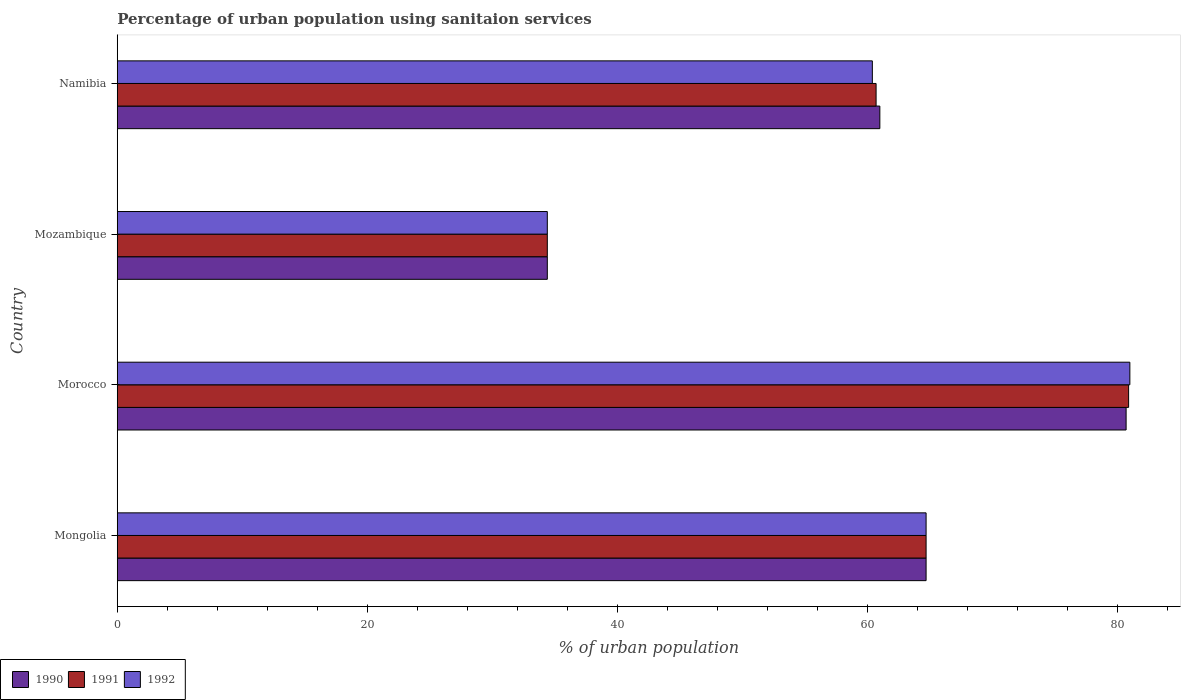How many different coloured bars are there?
Give a very brief answer. 3. Are the number of bars on each tick of the Y-axis equal?
Your answer should be very brief. Yes. How many bars are there on the 2nd tick from the top?
Offer a very short reply. 3. What is the label of the 1st group of bars from the top?
Keep it short and to the point. Namibia. In how many cases, is the number of bars for a given country not equal to the number of legend labels?
Make the answer very short. 0. What is the percentage of urban population using sanitaion services in 1990 in Mozambique?
Keep it short and to the point. 34.4. Across all countries, what is the maximum percentage of urban population using sanitaion services in 1990?
Offer a terse response. 80.7. Across all countries, what is the minimum percentage of urban population using sanitaion services in 1991?
Make the answer very short. 34.4. In which country was the percentage of urban population using sanitaion services in 1990 maximum?
Give a very brief answer. Morocco. In which country was the percentage of urban population using sanitaion services in 1991 minimum?
Provide a short and direct response. Mozambique. What is the total percentage of urban population using sanitaion services in 1992 in the graph?
Provide a short and direct response. 240.5. What is the difference between the percentage of urban population using sanitaion services in 1992 in Morocco and that in Mozambique?
Offer a very short reply. 46.6. What is the difference between the percentage of urban population using sanitaion services in 1990 in Morocco and the percentage of urban population using sanitaion services in 1992 in Mozambique?
Offer a terse response. 46.3. What is the average percentage of urban population using sanitaion services in 1992 per country?
Make the answer very short. 60.12. What is the difference between the percentage of urban population using sanitaion services in 1990 and percentage of urban population using sanitaion services in 1991 in Namibia?
Provide a short and direct response. 0.3. In how many countries, is the percentage of urban population using sanitaion services in 1990 greater than 32 %?
Your response must be concise. 4. What is the ratio of the percentage of urban population using sanitaion services in 1990 in Mozambique to that in Namibia?
Provide a succinct answer. 0.56. Is the percentage of urban population using sanitaion services in 1992 in Mongolia less than that in Morocco?
Offer a very short reply. Yes. What is the difference between the highest and the second highest percentage of urban population using sanitaion services in 1990?
Provide a short and direct response. 16. What is the difference between the highest and the lowest percentage of urban population using sanitaion services in 1992?
Your answer should be compact. 46.6. In how many countries, is the percentage of urban population using sanitaion services in 1990 greater than the average percentage of urban population using sanitaion services in 1990 taken over all countries?
Your answer should be very brief. 3. What does the 2nd bar from the bottom in Namibia represents?
Offer a terse response. 1991. Is it the case that in every country, the sum of the percentage of urban population using sanitaion services in 1990 and percentage of urban population using sanitaion services in 1991 is greater than the percentage of urban population using sanitaion services in 1992?
Your answer should be compact. Yes. Are all the bars in the graph horizontal?
Ensure brevity in your answer.  Yes. How many countries are there in the graph?
Give a very brief answer. 4. Are the values on the major ticks of X-axis written in scientific E-notation?
Your answer should be very brief. No. Does the graph contain any zero values?
Offer a terse response. No. How many legend labels are there?
Ensure brevity in your answer.  3. How are the legend labels stacked?
Offer a very short reply. Horizontal. What is the title of the graph?
Provide a short and direct response. Percentage of urban population using sanitaion services. Does "2015" appear as one of the legend labels in the graph?
Make the answer very short. No. What is the label or title of the X-axis?
Keep it short and to the point. % of urban population. What is the % of urban population in 1990 in Mongolia?
Your response must be concise. 64.7. What is the % of urban population of 1991 in Mongolia?
Provide a short and direct response. 64.7. What is the % of urban population in 1992 in Mongolia?
Your answer should be compact. 64.7. What is the % of urban population of 1990 in Morocco?
Your answer should be very brief. 80.7. What is the % of urban population of 1991 in Morocco?
Give a very brief answer. 80.9. What is the % of urban population in 1992 in Morocco?
Your answer should be compact. 81. What is the % of urban population of 1990 in Mozambique?
Offer a terse response. 34.4. What is the % of urban population in 1991 in Mozambique?
Keep it short and to the point. 34.4. What is the % of urban population in 1992 in Mozambique?
Make the answer very short. 34.4. What is the % of urban population of 1990 in Namibia?
Your response must be concise. 61. What is the % of urban population of 1991 in Namibia?
Your answer should be very brief. 60.7. What is the % of urban population of 1992 in Namibia?
Your answer should be very brief. 60.4. Across all countries, what is the maximum % of urban population of 1990?
Ensure brevity in your answer.  80.7. Across all countries, what is the maximum % of urban population in 1991?
Offer a very short reply. 80.9. Across all countries, what is the minimum % of urban population in 1990?
Ensure brevity in your answer.  34.4. Across all countries, what is the minimum % of urban population in 1991?
Your answer should be compact. 34.4. Across all countries, what is the minimum % of urban population in 1992?
Provide a succinct answer. 34.4. What is the total % of urban population of 1990 in the graph?
Keep it short and to the point. 240.8. What is the total % of urban population of 1991 in the graph?
Ensure brevity in your answer.  240.7. What is the total % of urban population in 1992 in the graph?
Ensure brevity in your answer.  240.5. What is the difference between the % of urban population of 1991 in Mongolia and that in Morocco?
Offer a terse response. -16.2. What is the difference between the % of urban population of 1992 in Mongolia and that in Morocco?
Ensure brevity in your answer.  -16.3. What is the difference between the % of urban population in 1990 in Mongolia and that in Mozambique?
Your response must be concise. 30.3. What is the difference between the % of urban population of 1991 in Mongolia and that in Mozambique?
Provide a succinct answer. 30.3. What is the difference between the % of urban population of 1992 in Mongolia and that in Mozambique?
Keep it short and to the point. 30.3. What is the difference between the % of urban population in 1991 in Mongolia and that in Namibia?
Offer a terse response. 4. What is the difference between the % of urban population of 1992 in Mongolia and that in Namibia?
Your answer should be compact. 4.3. What is the difference between the % of urban population of 1990 in Morocco and that in Mozambique?
Make the answer very short. 46.3. What is the difference between the % of urban population of 1991 in Morocco and that in Mozambique?
Offer a very short reply. 46.5. What is the difference between the % of urban population of 1992 in Morocco and that in Mozambique?
Provide a succinct answer. 46.6. What is the difference between the % of urban population in 1991 in Morocco and that in Namibia?
Make the answer very short. 20.2. What is the difference between the % of urban population of 1992 in Morocco and that in Namibia?
Offer a terse response. 20.6. What is the difference between the % of urban population of 1990 in Mozambique and that in Namibia?
Offer a very short reply. -26.6. What is the difference between the % of urban population in 1991 in Mozambique and that in Namibia?
Offer a terse response. -26.3. What is the difference between the % of urban population of 1990 in Mongolia and the % of urban population of 1991 in Morocco?
Offer a very short reply. -16.2. What is the difference between the % of urban population of 1990 in Mongolia and the % of urban population of 1992 in Morocco?
Ensure brevity in your answer.  -16.3. What is the difference between the % of urban population in 1991 in Mongolia and the % of urban population in 1992 in Morocco?
Your answer should be compact. -16.3. What is the difference between the % of urban population of 1990 in Mongolia and the % of urban population of 1991 in Mozambique?
Offer a very short reply. 30.3. What is the difference between the % of urban population in 1990 in Mongolia and the % of urban population in 1992 in Mozambique?
Offer a very short reply. 30.3. What is the difference between the % of urban population in 1991 in Mongolia and the % of urban population in 1992 in Mozambique?
Keep it short and to the point. 30.3. What is the difference between the % of urban population in 1990 in Mongolia and the % of urban population in 1991 in Namibia?
Provide a short and direct response. 4. What is the difference between the % of urban population in 1991 in Mongolia and the % of urban population in 1992 in Namibia?
Make the answer very short. 4.3. What is the difference between the % of urban population in 1990 in Morocco and the % of urban population in 1991 in Mozambique?
Ensure brevity in your answer.  46.3. What is the difference between the % of urban population in 1990 in Morocco and the % of urban population in 1992 in Mozambique?
Give a very brief answer. 46.3. What is the difference between the % of urban population in 1991 in Morocco and the % of urban population in 1992 in Mozambique?
Provide a succinct answer. 46.5. What is the difference between the % of urban population of 1990 in Morocco and the % of urban population of 1991 in Namibia?
Provide a succinct answer. 20. What is the difference between the % of urban population of 1990 in Morocco and the % of urban population of 1992 in Namibia?
Provide a succinct answer. 20.3. What is the difference between the % of urban population of 1991 in Morocco and the % of urban population of 1992 in Namibia?
Keep it short and to the point. 20.5. What is the difference between the % of urban population of 1990 in Mozambique and the % of urban population of 1991 in Namibia?
Provide a succinct answer. -26.3. What is the difference between the % of urban population of 1990 in Mozambique and the % of urban population of 1992 in Namibia?
Provide a short and direct response. -26. What is the difference between the % of urban population in 1991 in Mozambique and the % of urban population in 1992 in Namibia?
Your answer should be compact. -26. What is the average % of urban population in 1990 per country?
Give a very brief answer. 60.2. What is the average % of urban population in 1991 per country?
Provide a succinct answer. 60.17. What is the average % of urban population of 1992 per country?
Ensure brevity in your answer.  60.12. What is the difference between the % of urban population of 1990 and % of urban population of 1991 in Mongolia?
Offer a very short reply. 0. What is the difference between the % of urban population of 1990 and % of urban population of 1992 in Mongolia?
Your answer should be very brief. 0. What is the difference between the % of urban population of 1990 and % of urban population of 1992 in Mozambique?
Offer a very short reply. 0. What is the difference between the % of urban population in 1990 and % of urban population in 1991 in Namibia?
Provide a succinct answer. 0.3. What is the difference between the % of urban population in 1990 and % of urban population in 1992 in Namibia?
Make the answer very short. 0.6. What is the difference between the % of urban population of 1991 and % of urban population of 1992 in Namibia?
Make the answer very short. 0.3. What is the ratio of the % of urban population of 1990 in Mongolia to that in Morocco?
Give a very brief answer. 0.8. What is the ratio of the % of urban population in 1991 in Mongolia to that in Morocco?
Make the answer very short. 0.8. What is the ratio of the % of urban population of 1992 in Mongolia to that in Morocco?
Your answer should be very brief. 0.8. What is the ratio of the % of urban population in 1990 in Mongolia to that in Mozambique?
Keep it short and to the point. 1.88. What is the ratio of the % of urban population in 1991 in Mongolia to that in Mozambique?
Your answer should be very brief. 1.88. What is the ratio of the % of urban population in 1992 in Mongolia to that in Mozambique?
Keep it short and to the point. 1.88. What is the ratio of the % of urban population in 1990 in Mongolia to that in Namibia?
Your answer should be compact. 1.06. What is the ratio of the % of urban population of 1991 in Mongolia to that in Namibia?
Provide a succinct answer. 1.07. What is the ratio of the % of urban population in 1992 in Mongolia to that in Namibia?
Make the answer very short. 1.07. What is the ratio of the % of urban population of 1990 in Morocco to that in Mozambique?
Your answer should be very brief. 2.35. What is the ratio of the % of urban population of 1991 in Morocco to that in Mozambique?
Provide a succinct answer. 2.35. What is the ratio of the % of urban population of 1992 in Morocco to that in Mozambique?
Offer a very short reply. 2.35. What is the ratio of the % of urban population in 1990 in Morocco to that in Namibia?
Offer a very short reply. 1.32. What is the ratio of the % of urban population of 1991 in Morocco to that in Namibia?
Provide a succinct answer. 1.33. What is the ratio of the % of urban population in 1992 in Morocco to that in Namibia?
Give a very brief answer. 1.34. What is the ratio of the % of urban population in 1990 in Mozambique to that in Namibia?
Keep it short and to the point. 0.56. What is the ratio of the % of urban population in 1991 in Mozambique to that in Namibia?
Your response must be concise. 0.57. What is the ratio of the % of urban population of 1992 in Mozambique to that in Namibia?
Your answer should be compact. 0.57. What is the difference between the highest and the second highest % of urban population in 1990?
Provide a short and direct response. 16. What is the difference between the highest and the lowest % of urban population in 1990?
Offer a terse response. 46.3. What is the difference between the highest and the lowest % of urban population of 1991?
Your answer should be compact. 46.5. What is the difference between the highest and the lowest % of urban population of 1992?
Your answer should be very brief. 46.6. 